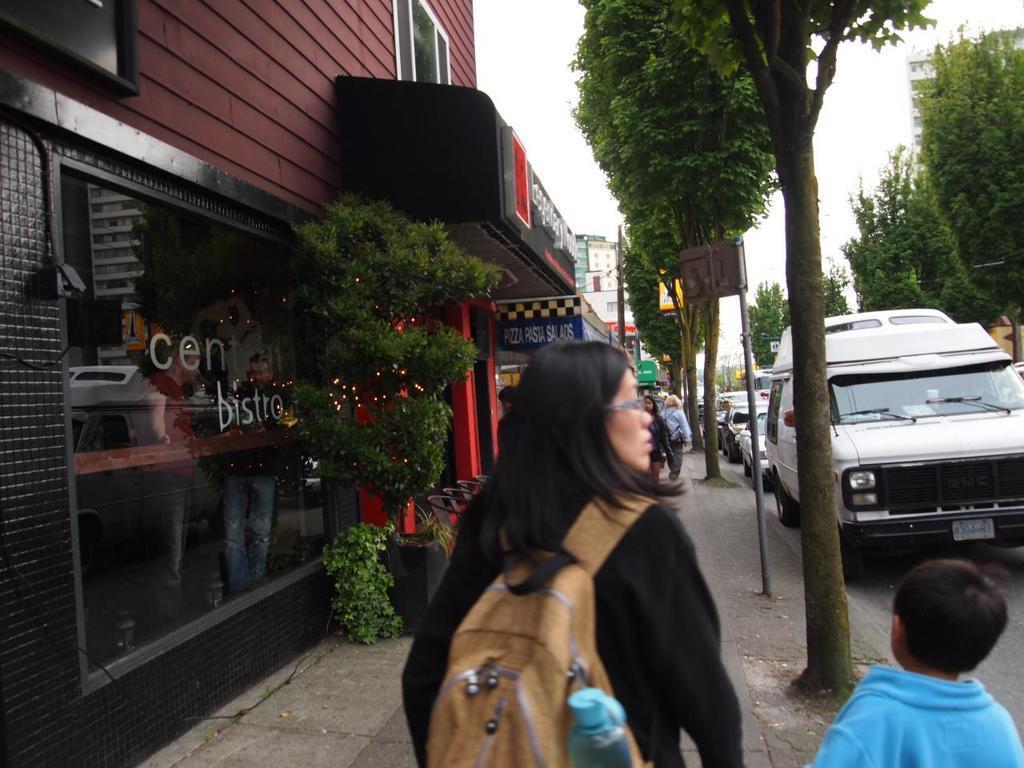What can be seen on the roadside in the image? There are vehicles on the roadside in the image. What are the people in the image doing? There are people walking in the image. What type of natural elements can be seen in the image? There are trees visible in the image. What type of man-made structures can be seen in the image? There are buildings in the image. What month is it in the image? The month cannot be determined from the image, as it does not provide any information about the time of year. How many minutes have passed since the people started walking in the image? The duration of time cannot be determined from the image, as it does not provide any information about the time elapsed. 